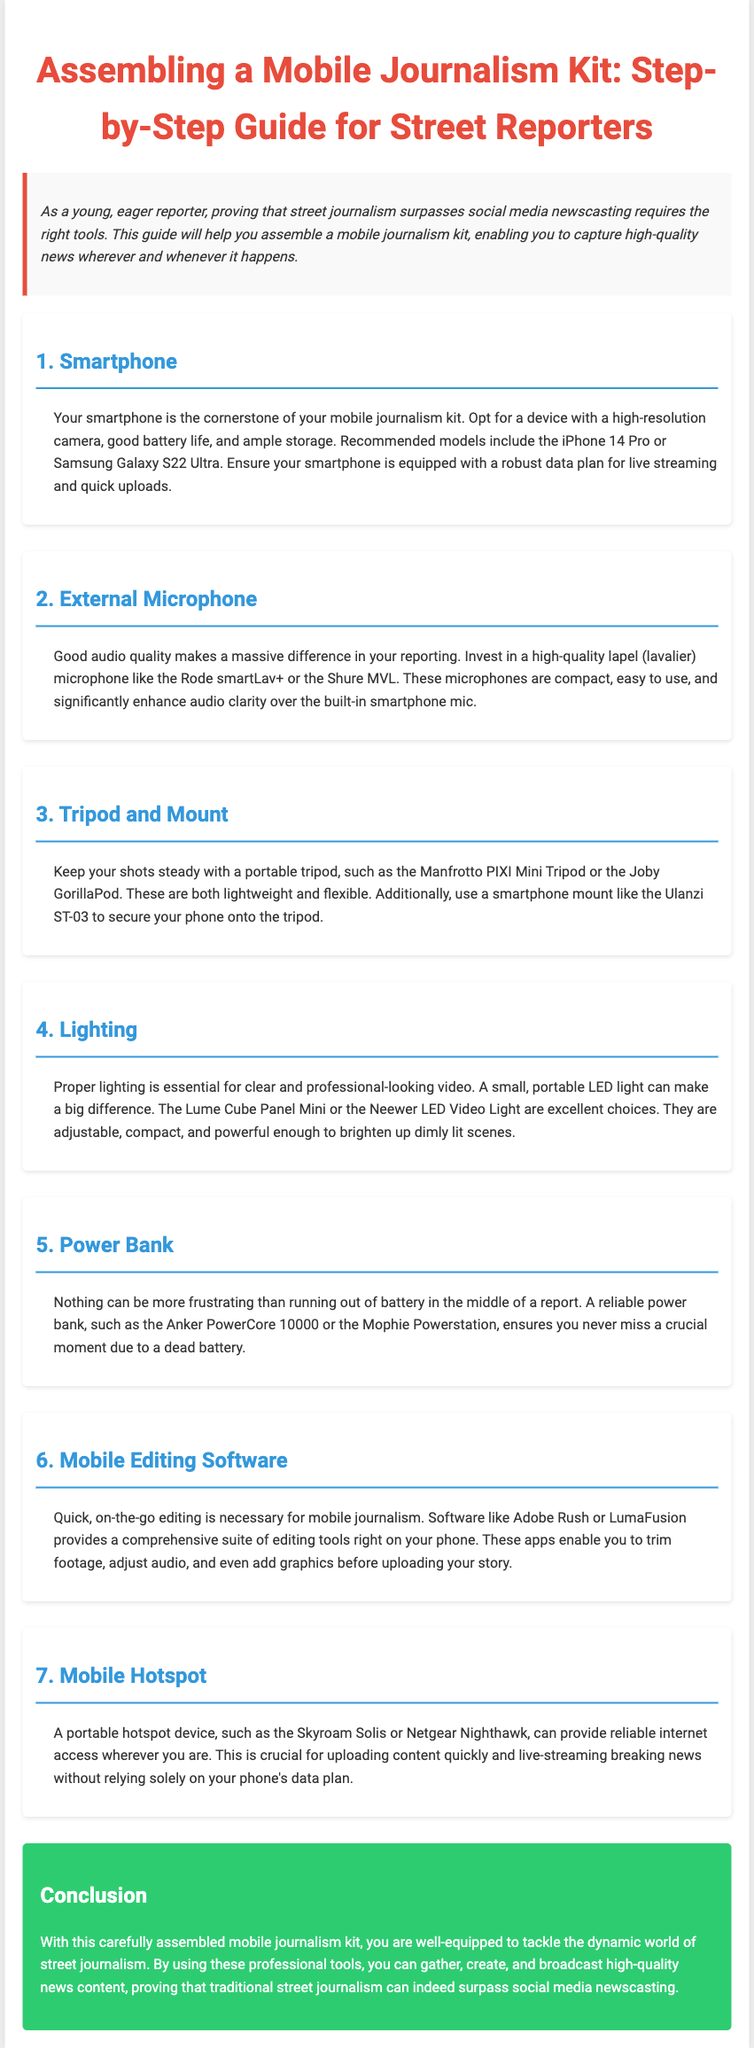What is the title of the document? The title of the document is at the top and summarizes the content, which is "Assembling a Mobile Journalism Kit: Step-by-Step Guide for Street Reporters."
Answer: Assembling a Mobile Journalism Kit: Step-by-Step Guide for Street Reporters What is the recommended smartphone model? The document lists specific models as recommendations for smartphones, including "iPhone 14 Pro" and "Samsung Galaxy S22 Ultra."
Answer: iPhone 14 Pro, Samsung Galaxy S22 Ultra What type of microphone is suggested? The document mentions a specific type of microphone that enhances audio quality, which is a "lapel (lavalier) microphone."
Answer: lapel (lavalier) microphone How many sections are in the document? The sections in the document cover distinct items for the mobile journalism kit, totaling seven sections.
Answer: 7 What is one type of lighting recommended? The document lists lighting options, including "Lume Cube Panel Mini" and "Neewer LED Video Light" for proper video lighting.
Answer: Lume Cube Panel Mini What does a power bank ensure? The power bank is highlighted for its importance in preventing battery issues during reporting, ensuring "you never miss a crucial moment."
Answer: never miss a crucial moment Which app is suggested for mobile editing software? The document provides specific software options for editing, including "Adobe Rush" and "LumaFusion."
Answer: Adobe Rush, LumaFusion What type of device is a mobile hotspot? A mobile hotspot is described as a device that provides "reliable internet access" on the go.
Answer: reliable internet access What is the main purpose of this guide? The introduction explains the purpose of the guide, which is to assist young reporters in assembling a kit that enables them to "capture high-quality news."
Answer: capture high-quality news 